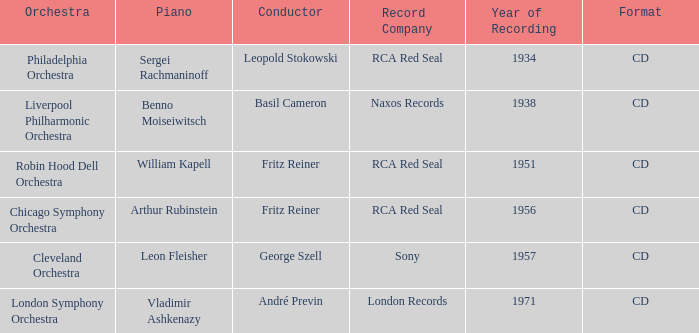Which orchestra has a recording year of 1951? Robin Hood Dell Orchestra. 